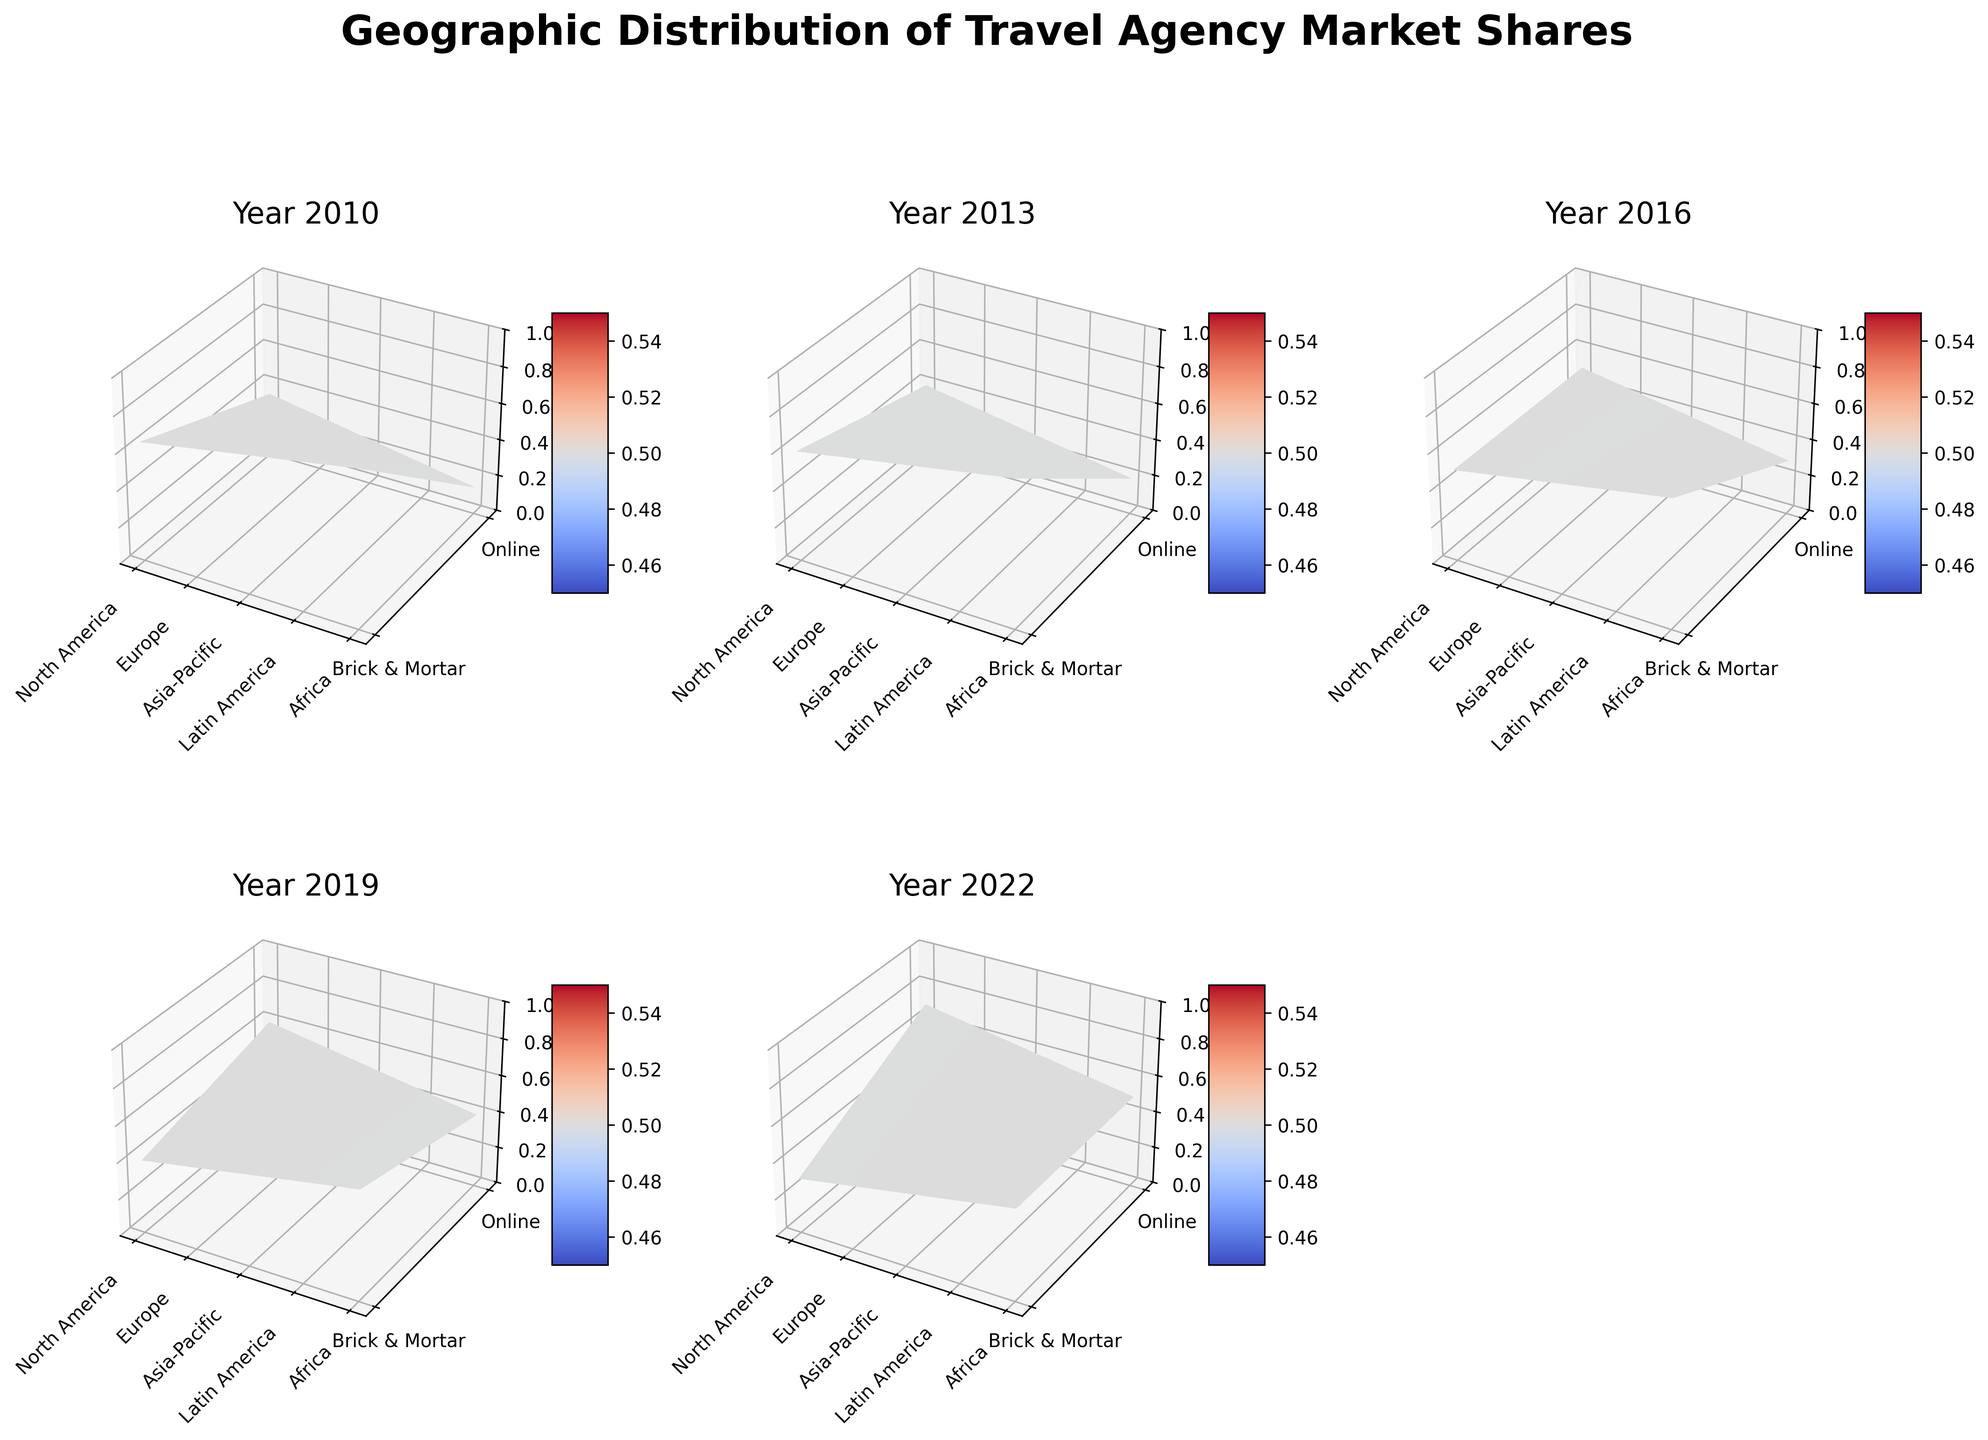What is the title of the entire figure? The title is typically placed at the top of the figure and provides an overview of what the plot represents. Here, it can be read directly.
Answer: Geographic Distribution of Travel Agency Market Shares Which year shows an equal market share for brick-and-mortar and online travel agencies in North America? You need to look at each subplot titled by year and check the surface plot for North America to find where brick-and-mortar and online market shares are equal.
Answer: 2016 In 2010, which region had the highest market share for brick-and-mortar travel agencies? Locate the subplot for 2010, then check the z-axis values for brick-and-mortar shares. Compare the values for all regions.
Answer: Africa How did the market share for online travel agencies in Europe change from 2010 to 2022? Observe the subplots for each year, focusing on Europe and the color gradient surface for online shares. Note the values from 2010 and 2022 and calculate the difference.
Answer: It increased by 0.35 (from 0.30 to 0.65) Which region saw the most significant drop in brick-and-mortar market share from 2010 to 2022? Examine each region's surface plot on the z-axis for brick-and-mortar shares across the years 2010 and 2022, then calculate the difference.
Answer: North America In 2019, how does the brick-and-mortar market share in Asia-Pacific compare to that in Europe? Check the subplot for 2019, observe the z-axis value for brick-and-mortar share in both Asia-Pacific and Europe, then compare them.
Answer: Asia-Pacific is higher Between 2016 and 2019, which region had the smallest increase in online market share? Examine the subplots for 2016 and 2019, checking the online market shares by region, then calculate and compare the differences.
Answer: Latin America What trend is evident in North America's market share for online travel agencies from 2010 to 2022? Look at the subplots for North America in each year and observe the change in online market share on the z-axis, noting increases or decreases over time.
Answer: Increasing trend In 2022, how does the market share for brick-and-mortar travel agencies in Africa compare to that in Latin America? Focus on the 2022 subplot, observe the z-axis values for brick-and-mortar shares in both Africa and Latin America, and compare.
Answer: Africa is higher 